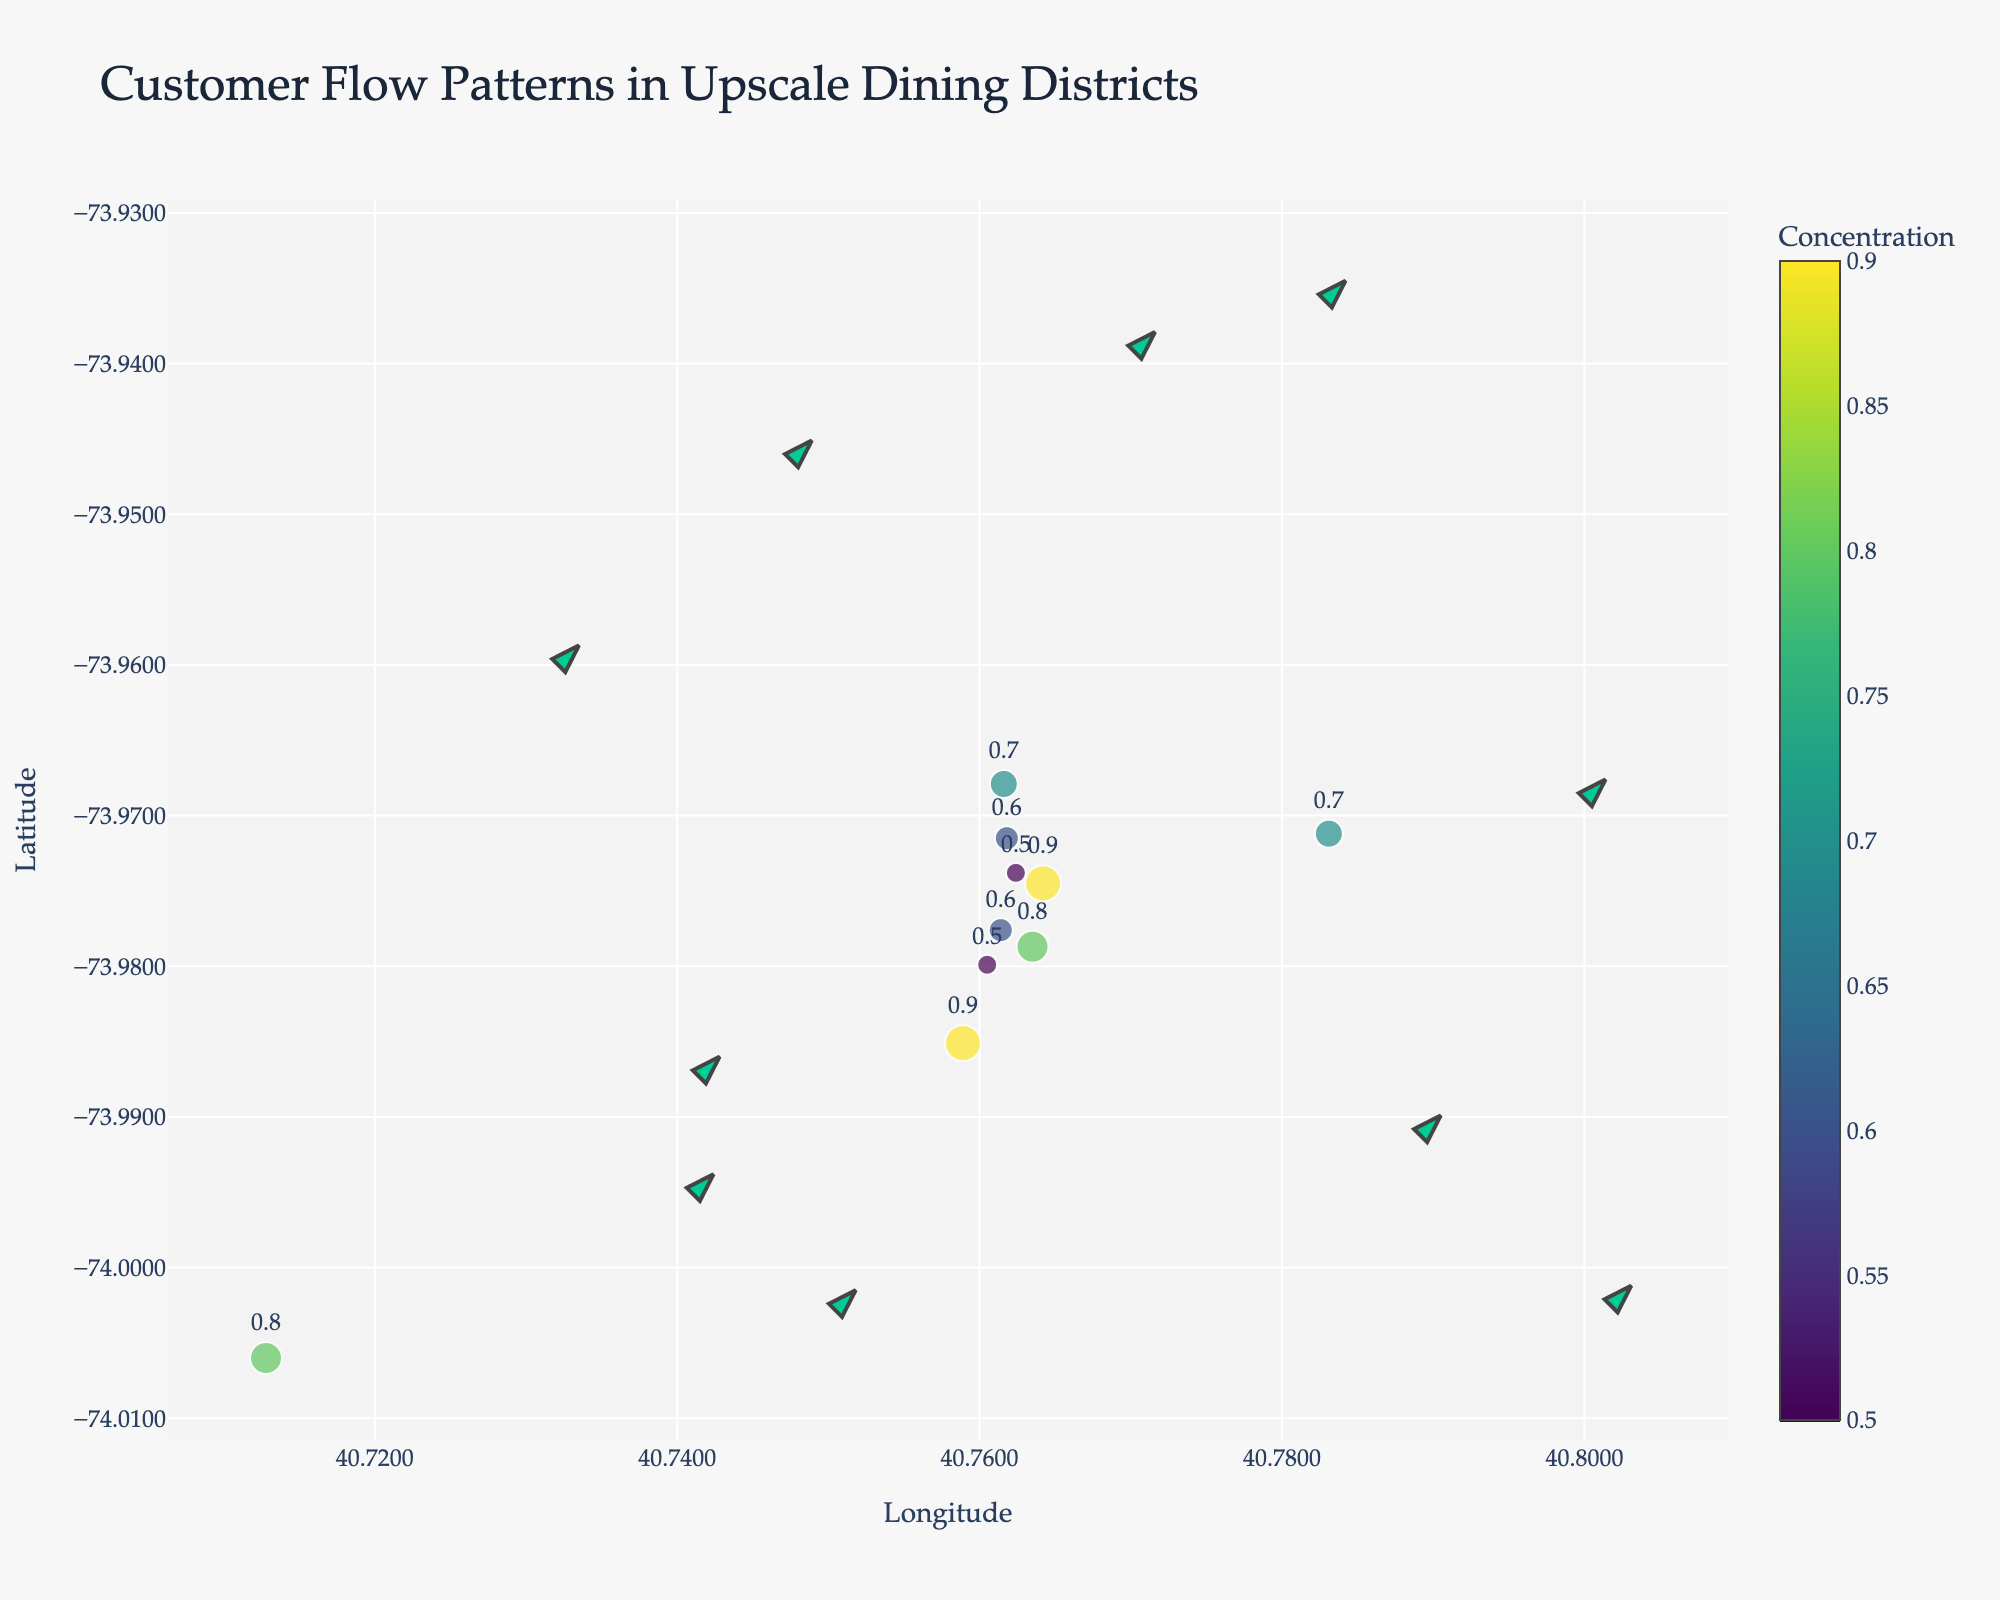What's the title of the plot? The title of the plot is displayed at the top of the figure. It's meant to provide a summary of what the plot is about.
Answer: Customer Flow Patterns in Upscale Dining Districts How many data points are represented in the plot? Count the number of arrows or markers in the plot, each representing a data point.
Answer: 10 Which location has the highest customer concentration? Look for the data point with the largest marker and the highest value in the concentration text.
Answer: 40.7589,-73.9851 What's the colorbar title of the plot? The colorbar title is located next to the color scale on the right side of the plot, indicating what the colors represent.
Answer: Concentration Which direction is the customer flow at coordinates (40.7614,-73.9776)? Check the position of the arrow at these coordinates and determine its direction by looking at the small arrows added for direction.
Answer: North-East What is the average customer concentration at all locations? Sum all concentration values and divide by the number of data points. (0.8+0.9+0.7+0.6+0.5+0.7+0.8+0.9+0.6+0.5)/10 = 7/10
Answer: 0.7 Compare the customer flow between coordinates (40.7614,-73.9776) and (40.7624,-73.9738). Which has a higher movement in the x-direction? Look at the u values for each location to determine which has a higher absolute movement in the x-direction. 0.4 vs. -0.2
Answer: (40.7614,-73.9776) Which location shows customers moving in the South-West direction? Identify the points where both u and v values are negative, indicating a South-West movement.
Answer: 40.7624,-73.9738 What is the total sum of the customer concentrations across all locations? Add all the concentration values. 0.8 + 0.9 + 0.7 + 0.6 + 0.5 + 0.7 + 0.8 + 0.9 + 0.6 + 0.5 = 7
Answer: 7 Which coordinates indicate customers moving most strongly towards the West? The highest negative u value will indicate the strongest westward movement. -0.3 at (40.7635,-73.9787)
Answer: (40.7635,-73.9787) 